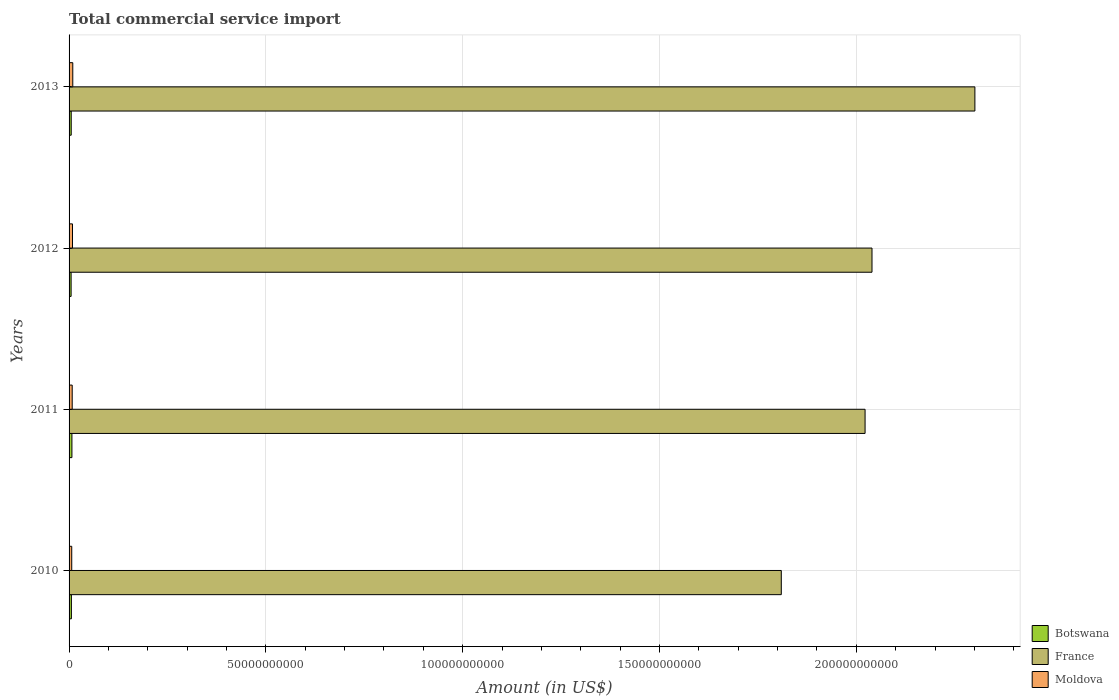Are the number of bars per tick equal to the number of legend labels?
Make the answer very short. Yes. In how many cases, is the number of bars for a given year not equal to the number of legend labels?
Your answer should be very brief. 0. What is the total commercial service import in Moldova in 2012?
Provide a short and direct response. 8.73e+08. Across all years, what is the maximum total commercial service import in France?
Make the answer very short. 2.30e+11. Across all years, what is the minimum total commercial service import in Moldova?
Make the answer very short. 6.78e+08. What is the total total commercial service import in France in the graph?
Give a very brief answer. 8.17e+11. What is the difference between the total commercial service import in France in 2012 and that in 2013?
Your response must be concise. -2.61e+1. What is the difference between the total commercial service import in Moldova in 2010 and the total commercial service import in France in 2012?
Provide a short and direct response. -2.03e+11. What is the average total commercial service import in Moldova per year?
Your response must be concise. 8.22e+08. In the year 2013, what is the difference between the total commercial service import in Botswana and total commercial service import in France?
Provide a succinct answer. -2.30e+11. In how many years, is the total commercial service import in Botswana greater than 230000000000 US$?
Your answer should be very brief. 0. What is the ratio of the total commercial service import in Botswana in 2011 to that in 2012?
Provide a short and direct response. 1.4. Is the total commercial service import in France in 2010 less than that in 2013?
Your response must be concise. Yes. What is the difference between the highest and the second highest total commercial service import in Botswana?
Ensure brevity in your answer.  1.35e+08. What is the difference between the highest and the lowest total commercial service import in Botswana?
Offer a terse response. 2.06e+08. Is the sum of the total commercial service import in Moldova in 2012 and 2013 greater than the maximum total commercial service import in Botswana across all years?
Make the answer very short. Yes. What does the 3rd bar from the top in 2011 represents?
Offer a very short reply. Botswana. What does the 2nd bar from the bottom in 2013 represents?
Offer a very short reply. France. Is it the case that in every year, the sum of the total commercial service import in Moldova and total commercial service import in Botswana is greater than the total commercial service import in France?
Ensure brevity in your answer.  No. How many bars are there?
Offer a very short reply. 12. Are all the bars in the graph horizontal?
Make the answer very short. Yes. What is the difference between two consecutive major ticks on the X-axis?
Give a very brief answer. 5.00e+1. Are the values on the major ticks of X-axis written in scientific E-notation?
Offer a very short reply. No. Does the graph contain grids?
Offer a terse response. Yes. Where does the legend appear in the graph?
Ensure brevity in your answer.  Bottom right. How many legend labels are there?
Offer a very short reply. 3. How are the legend labels stacked?
Keep it short and to the point. Vertical. What is the title of the graph?
Offer a very short reply. Total commercial service import. What is the label or title of the X-axis?
Your response must be concise. Amount (in US$). What is the Amount (in US$) of Botswana in 2010?
Your response must be concise. 5.91e+08. What is the Amount (in US$) of France in 2010?
Offer a terse response. 1.81e+11. What is the Amount (in US$) of Moldova in 2010?
Keep it short and to the point. 6.78e+08. What is the Amount (in US$) in Botswana in 2011?
Offer a terse response. 7.25e+08. What is the Amount (in US$) in France in 2011?
Your response must be concise. 2.02e+11. What is the Amount (in US$) of Moldova in 2011?
Make the answer very short. 7.95e+08. What is the Amount (in US$) of Botswana in 2012?
Ensure brevity in your answer.  5.19e+08. What is the Amount (in US$) of France in 2012?
Make the answer very short. 2.04e+11. What is the Amount (in US$) in Moldova in 2012?
Ensure brevity in your answer.  8.73e+08. What is the Amount (in US$) of Botswana in 2013?
Make the answer very short. 5.45e+08. What is the Amount (in US$) in France in 2013?
Your response must be concise. 2.30e+11. What is the Amount (in US$) in Moldova in 2013?
Offer a very short reply. 9.42e+08. Across all years, what is the maximum Amount (in US$) of Botswana?
Provide a succinct answer. 7.25e+08. Across all years, what is the maximum Amount (in US$) of France?
Provide a succinct answer. 2.30e+11. Across all years, what is the maximum Amount (in US$) of Moldova?
Keep it short and to the point. 9.42e+08. Across all years, what is the minimum Amount (in US$) of Botswana?
Provide a short and direct response. 5.19e+08. Across all years, what is the minimum Amount (in US$) in France?
Provide a short and direct response. 1.81e+11. Across all years, what is the minimum Amount (in US$) of Moldova?
Keep it short and to the point. 6.78e+08. What is the total Amount (in US$) of Botswana in the graph?
Give a very brief answer. 2.38e+09. What is the total Amount (in US$) of France in the graph?
Offer a very short reply. 8.17e+11. What is the total Amount (in US$) in Moldova in the graph?
Your response must be concise. 3.29e+09. What is the difference between the Amount (in US$) in Botswana in 2010 and that in 2011?
Your response must be concise. -1.35e+08. What is the difference between the Amount (in US$) in France in 2010 and that in 2011?
Your answer should be very brief. -2.13e+1. What is the difference between the Amount (in US$) in Moldova in 2010 and that in 2011?
Make the answer very short. -1.17e+08. What is the difference between the Amount (in US$) in Botswana in 2010 and that in 2012?
Provide a short and direct response. 7.15e+07. What is the difference between the Amount (in US$) of France in 2010 and that in 2012?
Offer a very short reply. -2.30e+1. What is the difference between the Amount (in US$) of Moldova in 2010 and that in 2012?
Your answer should be very brief. -1.95e+08. What is the difference between the Amount (in US$) of Botswana in 2010 and that in 2013?
Provide a short and direct response. 4.52e+07. What is the difference between the Amount (in US$) in France in 2010 and that in 2013?
Your response must be concise. -4.92e+1. What is the difference between the Amount (in US$) of Moldova in 2010 and that in 2013?
Offer a terse response. -2.64e+08. What is the difference between the Amount (in US$) in Botswana in 2011 and that in 2012?
Give a very brief answer. 2.06e+08. What is the difference between the Amount (in US$) in France in 2011 and that in 2012?
Keep it short and to the point. -1.76e+09. What is the difference between the Amount (in US$) of Moldova in 2011 and that in 2012?
Make the answer very short. -7.80e+07. What is the difference between the Amount (in US$) in Botswana in 2011 and that in 2013?
Keep it short and to the point. 1.80e+08. What is the difference between the Amount (in US$) of France in 2011 and that in 2013?
Keep it short and to the point. -2.79e+1. What is the difference between the Amount (in US$) of Moldova in 2011 and that in 2013?
Your response must be concise. -1.47e+08. What is the difference between the Amount (in US$) of Botswana in 2012 and that in 2013?
Your answer should be compact. -2.63e+07. What is the difference between the Amount (in US$) in France in 2012 and that in 2013?
Keep it short and to the point. -2.61e+1. What is the difference between the Amount (in US$) of Moldova in 2012 and that in 2013?
Provide a succinct answer. -6.94e+07. What is the difference between the Amount (in US$) in Botswana in 2010 and the Amount (in US$) in France in 2011?
Ensure brevity in your answer.  -2.02e+11. What is the difference between the Amount (in US$) of Botswana in 2010 and the Amount (in US$) of Moldova in 2011?
Your answer should be compact. -2.04e+08. What is the difference between the Amount (in US$) in France in 2010 and the Amount (in US$) in Moldova in 2011?
Offer a very short reply. 1.80e+11. What is the difference between the Amount (in US$) in Botswana in 2010 and the Amount (in US$) in France in 2012?
Make the answer very short. -2.03e+11. What is the difference between the Amount (in US$) in Botswana in 2010 and the Amount (in US$) in Moldova in 2012?
Keep it short and to the point. -2.82e+08. What is the difference between the Amount (in US$) in France in 2010 and the Amount (in US$) in Moldova in 2012?
Give a very brief answer. 1.80e+11. What is the difference between the Amount (in US$) of Botswana in 2010 and the Amount (in US$) of France in 2013?
Keep it short and to the point. -2.30e+11. What is the difference between the Amount (in US$) in Botswana in 2010 and the Amount (in US$) in Moldova in 2013?
Your answer should be compact. -3.51e+08. What is the difference between the Amount (in US$) in France in 2010 and the Amount (in US$) in Moldova in 2013?
Offer a terse response. 1.80e+11. What is the difference between the Amount (in US$) of Botswana in 2011 and the Amount (in US$) of France in 2012?
Give a very brief answer. -2.03e+11. What is the difference between the Amount (in US$) in Botswana in 2011 and the Amount (in US$) in Moldova in 2012?
Provide a short and direct response. -1.47e+08. What is the difference between the Amount (in US$) in France in 2011 and the Amount (in US$) in Moldova in 2012?
Keep it short and to the point. 2.01e+11. What is the difference between the Amount (in US$) of Botswana in 2011 and the Amount (in US$) of France in 2013?
Offer a terse response. -2.29e+11. What is the difference between the Amount (in US$) in Botswana in 2011 and the Amount (in US$) in Moldova in 2013?
Offer a terse response. -2.17e+08. What is the difference between the Amount (in US$) in France in 2011 and the Amount (in US$) in Moldova in 2013?
Offer a terse response. 2.01e+11. What is the difference between the Amount (in US$) in Botswana in 2012 and the Amount (in US$) in France in 2013?
Ensure brevity in your answer.  -2.30e+11. What is the difference between the Amount (in US$) of Botswana in 2012 and the Amount (in US$) of Moldova in 2013?
Offer a terse response. -4.23e+08. What is the difference between the Amount (in US$) in France in 2012 and the Amount (in US$) in Moldova in 2013?
Make the answer very short. 2.03e+11. What is the average Amount (in US$) of Botswana per year?
Offer a terse response. 5.95e+08. What is the average Amount (in US$) in France per year?
Your response must be concise. 2.04e+11. What is the average Amount (in US$) in Moldova per year?
Provide a short and direct response. 8.22e+08. In the year 2010, what is the difference between the Amount (in US$) of Botswana and Amount (in US$) of France?
Keep it short and to the point. -1.80e+11. In the year 2010, what is the difference between the Amount (in US$) of Botswana and Amount (in US$) of Moldova?
Your answer should be compact. -8.70e+07. In the year 2010, what is the difference between the Amount (in US$) in France and Amount (in US$) in Moldova?
Offer a very short reply. 1.80e+11. In the year 2011, what is the difference between the Amount (in US$) of Botswana and Amount (in US$) of France?
Provide a succinct answer. -2.01e+11. In the year 2011, what is the difference between the Amount (in US$) of Botswana and Amount (in US$) of Moldova?
Offer a very short reply. -6.93e+07. In the year 2011, what is the difference between the Amount (in US$) in France and Amount (in US$) in Moldova?
Offer a terse response. 2.01e+11. In the year 2012, what is the difference between the Amount (in US$) in Botswana and Amount (in US$) in France?
Offer a terse response. -2.03e+11. In the year 2012, what is the difference between the Amount (in US$) in Botswana and Amount (in US$) in Moldova?
Provide a short and direct response. -3.54e+08. In the year 2012, what is the difference between the Amount (in US$) of France and Amount (in US$) of Moldova?
Provide a succinct answer. 2.03e+11. In the year 2013, what is the difference between the Amount (in US$) in Botswana and Amount (in US$) in France?
Provide a succinct answer. -2.30e+11. In the year 2013, what is the difference between the Amount (in US$) of Botswana and Amount (in US$) of Moldova?
Keep it short and to the point. -3.97e+08. In the year 2013, what is the difference between the Amount (in US$) in France and Amount (in US$) in Moldova?
Your answer should be very brief. 2.29e+11. What is the ratio of the Amount (in US$) in Botswana in 2010 to that in 2011?
Provide a succinct answer. 0.81. What is the ratio of the Amount (in US$) of France in 2010 to that in 2011?
Offer a terse response. 0.89. What is the ratio of the Amount (in US$) of Moldova in 2010 to that in 2011?
Provide a succinct answer. 0.85. What is the ratio of the Amount (in US$) of Botswana in 2010 to that in 2012?
Ensure brevity in your answer.  1.14. What is the ratio of the Amount (in US$) of France in 2010 to that in 2012?
Give a very brief answer. 0.89. What is the ratio of the Amount (in US$) of Moldova in 2010 to that in 2012?
Your answer should be very brief. 0.78. What is the ratio of the Amount (in US$) in Botswana in 2010 to that in 2013?
Keep it short and to the point. 1.08. What is the ratio of the Amount (in US$) of France in 2010 to that in 2013?
Give a very brief answer. 0.79. What is the ratio of the Amount (in US$) in Moldova in 2010 to that in 2013?
Offer a terse response. 0.72. What is the ratio of the Amount (in US$) of Botswana in 2011 to that in 2012?
Offer a very short reply. 1.4. What is the ratio of the Amount (in US$) of France in 2011 to that in 2012?
Your answer should be compact. 0.99. What is the ratio of the Amount (in US$) in Moldova in 2011 to that in 2012?
Your answer should be compact. 0.91. What is the ratio of the Amount (in US$) of Botswana in 2011 to that in 2013?
Give a very brief answer. 1.33. What is the ratio of the Amount (in US$) of France in 2011 to that in 2013?
Offer a terse response. 0.88. What is the ratio of the Amount (in US$) of Moldova in 2011 to that in 2013?
Ensure brevity in your answer.  0.84. What is the ratio of the Amount (in US$) of Botswana in 2012 to that in 2013?
Make the answer very short. 0.95. What is the ratio of the Amount (in US$) of France in 2012 to that in 2013?
Keep it short and to the point. 0.89. What is the ratio of the Amount (in US$) in Moldova in 2012 to that in 2013?
Keep it short and to the point. 0.93. What is the difference between the highest and the second highest Amount (in US$) of Botswana?
Ensure brevity in your answer.  1.35e+08. What is the difference between the highest and the second highest Amount (in US$) of France?
Ensure brevity in your answer.  2.61e+1. What is the difference between the highest and the second highest Amount (in US$) of Moldova?
Offer a terse response. 6.94e+07. What is the difference between the highest and the lowest Amount (in US$) of Botswana?
Make the answer very short. 2.06e+08. What is the difference between the highest and the lowest Amount (in US$) of France?
Make the answer very short. 4.92e+1. What is the difference between the highest and the lowest Amount (in US$) of Moldova?
Ensure brevity in your answer.  2.64e+08. 